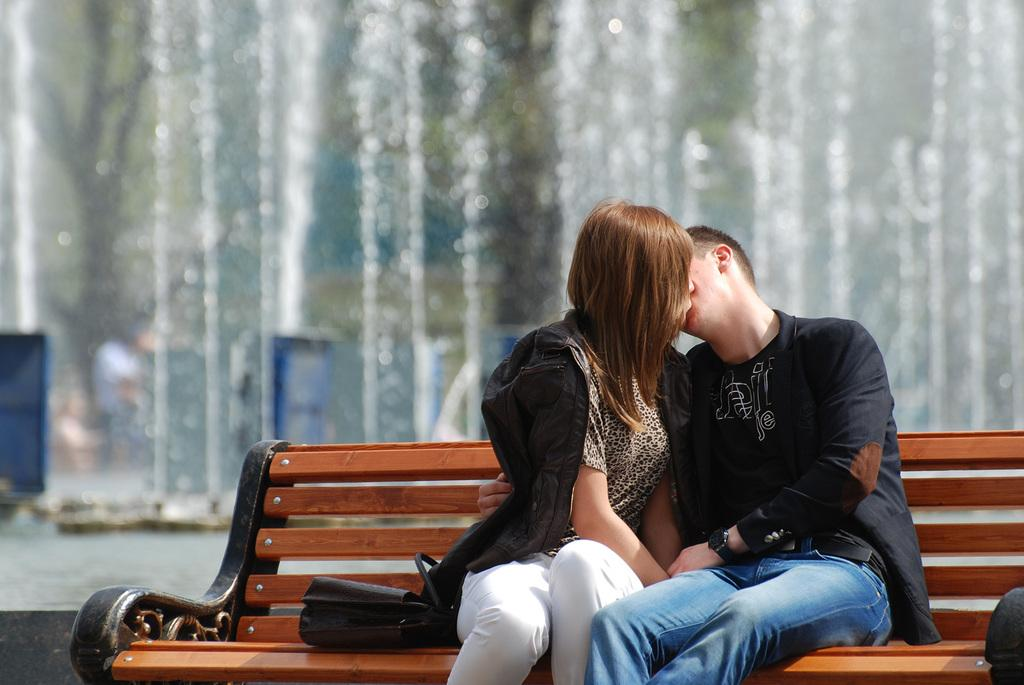What object can be seen in the image? There is a bag in the image. Who is present in the image? There are two persons sitting on a wooden bench. What is located behind the two persons? There is a fountain behind the two persons. How would you describe the background of the image? The background of the image is blurred. Can you tell me how many robins are perched on the mountain in the image? There is no mountain or robin present in the image. What type of request is being made by the persons in the image? There is no request being made in the image; it only shows two persons sitting on a wooden bench. 